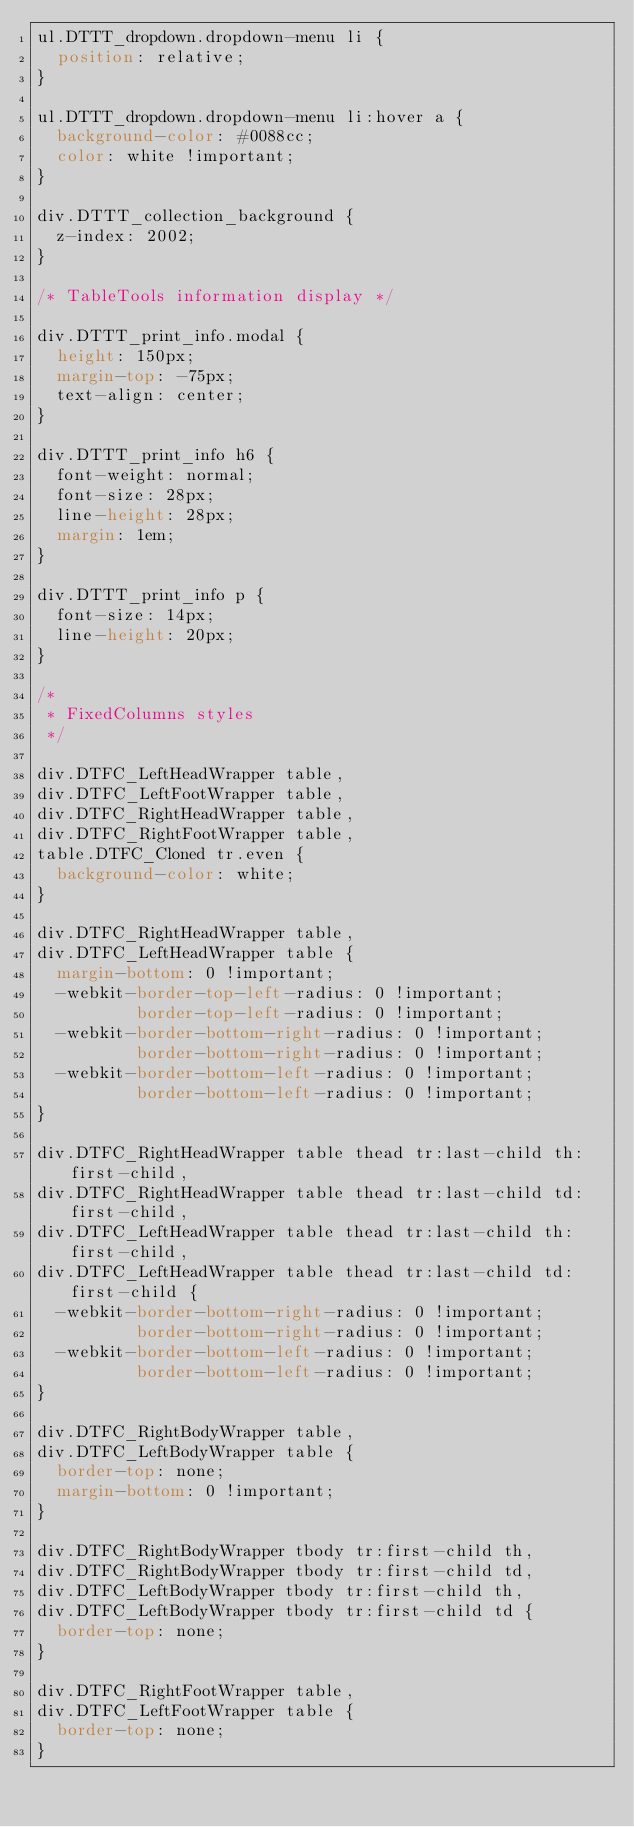<code> <loc_0><loc_0><loc_500><loc_500><_CSS_>ul.DTTT_dropdown.dropdown-menu li {
  position: relative;
}

ul.DTTT_dropdown.dropdown-menu li:hover a {
  background-color: #0088cc;
  color: white !important;
}

div.DTTT_collection_background {
  z-index: 2002;
}

/* TableTools information display */

div.DTTT_print_info.modal {
  height: 150px;
  margin-top: -75px;
  text-align: center;
}

div.DTTT_print_info h6 {
  font-weight: normal;
  font-size: 28px;
  line-height: 28px;
  margin: 1em;
}

div.DTTT_print_info p {
  font-size: 14px;
  line-height: 20px;
}

/*
 * FixedColumns styles
 */

div.DTFC_LeftHeadWrapper table,
div.DTFC_LeftFootWrapper table,
div.DTFC_RightHeadWrapper table,
div.DTFC_RightFootWrapper table,
table.DTFC_Cloned tr.even {
  background-color: white;
}

div.DTFC_RightHeadWrapper table,
div.DTFC_LeftHeadWrapper table {
  margin-bottom: 0 !important;
  -webkit-border-top-left-radius: 0 !important;
          border-top-left-radius: 0 !important;
  -webkit-border-bottom-right-radius: 0 !important;
          border-bottom-right-radius: 0 !important;
  -webkit-border-bottom-left-radius: 0 !important;
          border-bottom-left-radius: 0 !important;
}

div.DTFC_RightHeadWrapper table thead tr:last-child th:first-child,
div.DTFC_RightHeadWrapper table thead tr:last-child td:first-child,
div.DTFC_LeftHeadWrapper table thead tr:last-child th:first-child,
div.DTFC_LeftHeadWrapper table thead tr:last-child td:first-child {
  -webkit-border-bottom-right-radius: 0 !important;
          border-bottom-right-radius: 0 !important;
  -webkit-border-bottom-left-radius: 0 !important;
          border-bottom-left-radius: 0 !important;
}

div.DTFC_RightBodyWrapper table,
div.DTFC_LeftBodyWrapper table {
  border-top: none;
  margin-bottom: 0 !important;
}

div.DTFC_RightBodyWrapper tbody tr:first-child th,
div.DTFC_RightBodyWrapper tbody tr:first-child td,
div.DTFC_LeftBodyWrapper tbody tr:first-child th,
div.DTFC_LeftBodyWrapper tbody tr:first-child td {
  border-top: none;
}

div.DTFC_RightFootWrapper table,
div.DTFC_LeftFootWrapper table {
  border-top: none;
}</code> 